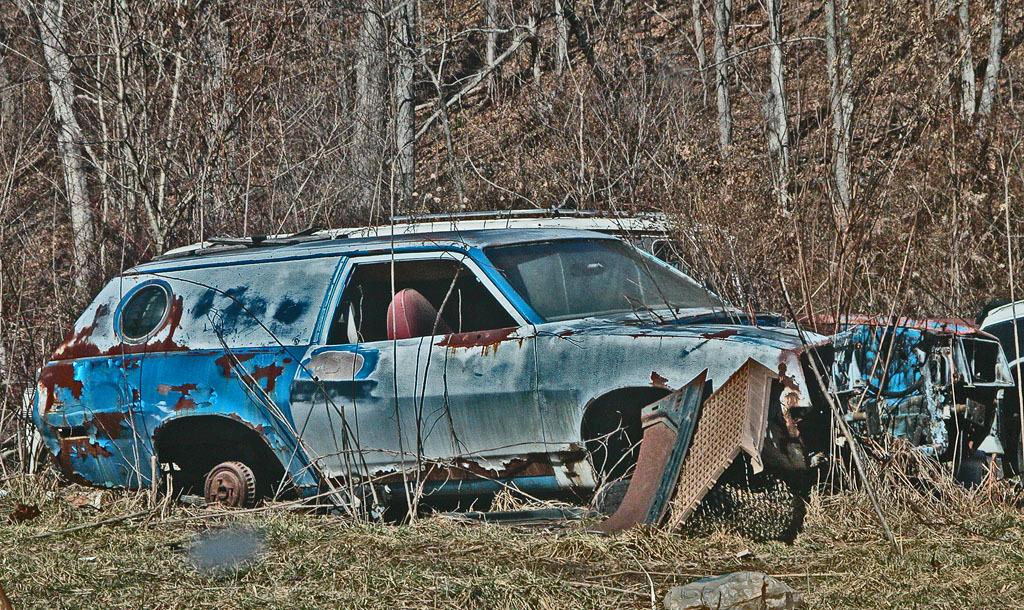What type of objects are on the ground in the image? There are abandoned vehicles and other metal items on the ground in the image. What can be seen in the background of the image? There are bare trees in the background of the image. What type of gold can be seen on the vehicles in the image? There is no gold present on the vehicles in the image. What causes the shock in the image? There is no shock depicted in the image. 